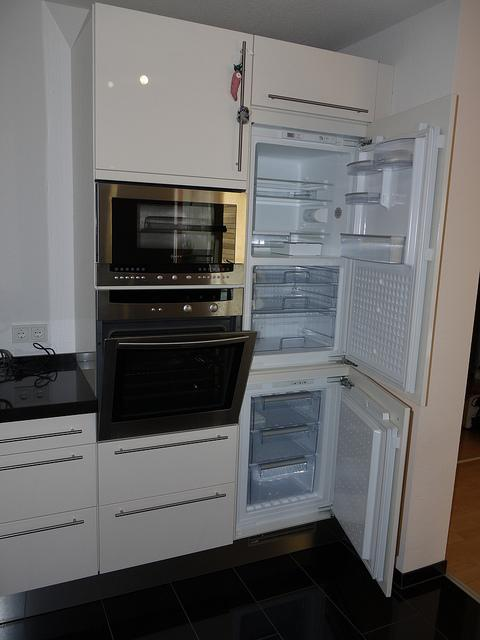The kitchen adheres to the electrical standards set in which region?

Choices:
A) australia
B) north america
C) europe
D) south america europe 